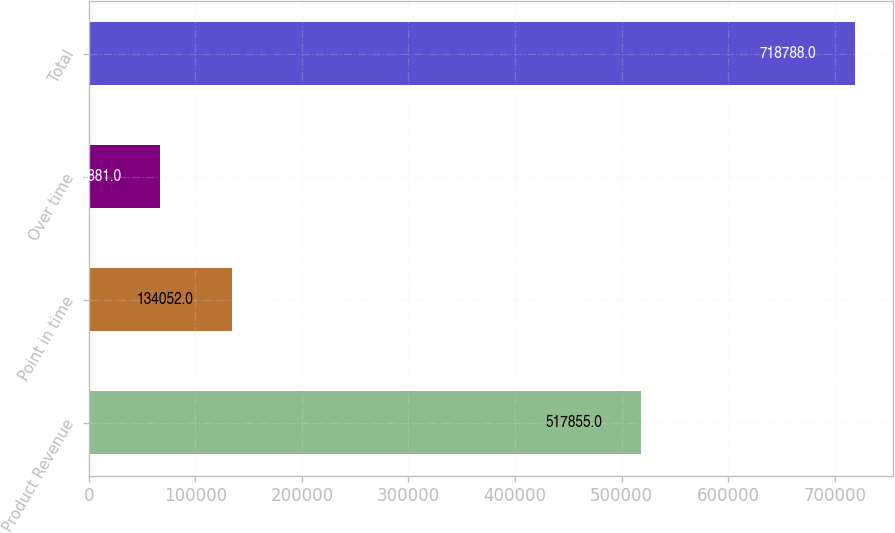Convert chart to OTSL. <chart><loc_0><loc_0><loc_500><loc_500><bar_chart><fcel>Product Revenue<fcel>Point in time<fcel>Over time<fcel>Total<nl><fcel>517855<fcel>134052<fcel>66881<fcel>718788<nl></chart> 